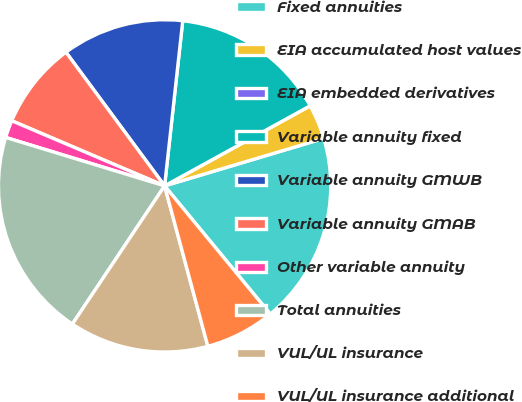Convert chart to OTSL. <chart><loc_0><loc_0><loc_500><loc_500><pie_chart><fcel>Fixed annuities<fcel>EIA accumulated host values<fcel>EIA embedded derivatives<fcel>Variable annuity fixed<fcel>Variable annuity GMWB<fcel>Variable annuity GMAB<fcel>Other variable annuity<fcel>Total annuities<fcel>VUL/UL insurance<fcel>VUL/UL insurance additional<nl><fcel>18.64%<fcel>3.39%<fcel>0.0%<fcel>15.25%<fcel>11.86%<fcel>8.47%<fcel>1.7%<fcel>20.34%<fcel>13.56%<fcel>6.78%<nl></chart> 